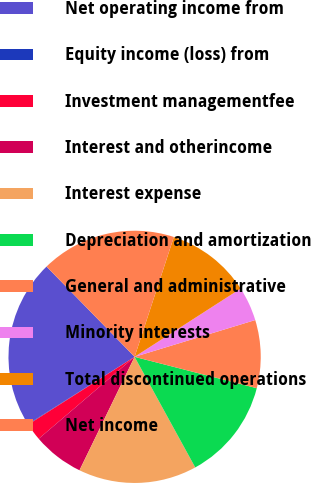Convert chart to OTSL. <chart><loc_0><loc_0><loc_500><loc_500><pie_chart><fcel>Net operating income from<fcel>Equity income (loss) from<fcel>Investment managementfee<fcel>Interest and otherincome<fcel>Interest expense<fcel>Depreciation and amortization<fcel>General and administrative<fcel>Minority interests<fcel>Total discontinued operations<fcel>Net income<nl><fcel>21.65%<fcel>0.07%<fcel>2.23%<fcel>6.55%<fcel>15.18%<fcel>13.02%<fcel>8.71%<fcel>4.39%<fcel>10.86%<fcel>17.34%<nl></chart> 